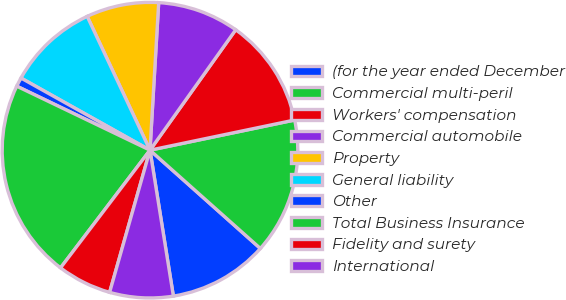Convert chart to OTSL. <chart><loc_0><loc_0><loc_500><loc_500><pie_chart><fcel>(for the year ended December<fcel>Commercial multi-peril<fcel>Workers' compensation<fcel>Commercial automobile<fcel>Property<fcel>General liability<fcel>Other<fcel>Total Business Insurance<fcel>Fidelity and surety<fcel>International<nl><fcel>10.89%<fcel>14.85%<fcel>11.88%<fcel>8.91%<fcel>7.92%<fcel>9.9%<fcel>0.99%<fcel>21.78%<fcel>5.94%<fcel>6.93%<nl></chart> 